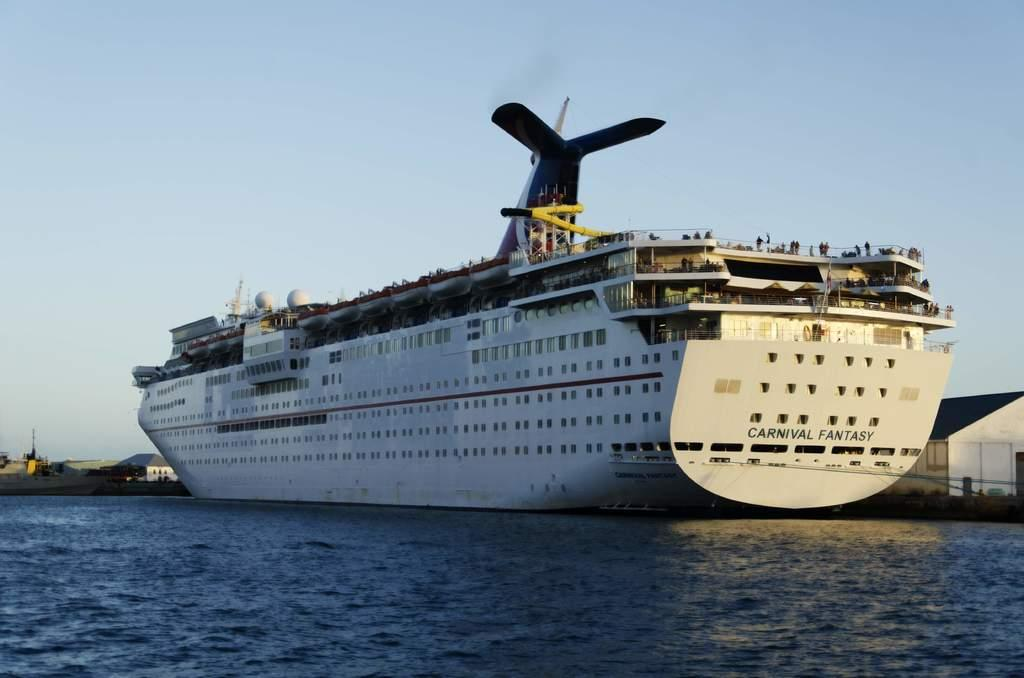<image>
Render a clear and concise summary of the photo. White ship that says Carnival Fantasy on the bottom cruising in the waters. 